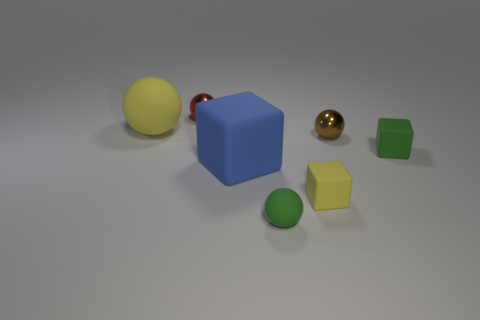Subtract all yellow blocks. Subtract all cyan cylinders. How many blocks are left? 2 Add 3 green matte balls. How many objects exist? 10 Subtract all blocks. How many objects are left? 4 Subtract all big red matte things. Subtract all brown metallic spheres. How many objects are left? 6 Add 2 tiny yellow rubber objects. How many tiny yellow rubber objects are left? 3 Add 4 small green cylinders. How many small green cylinders exist? 4 Subtract 0 purple cylinders. How many objects are left? 7 